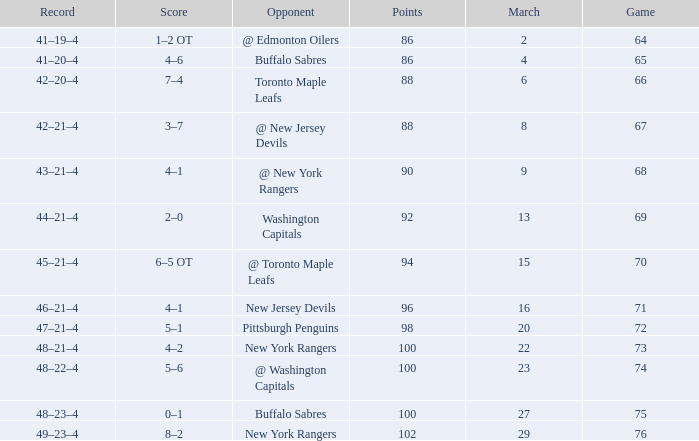Which Points have a Record of 45–21–4, and a Game larger than 70? None. 